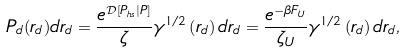Convert formula to latex. <formula><loc_0><loc_0><loc_500><loc_500>P _ { d } ( r _ { d } ) d r _ { d } = \frac { e ^ { \mathcal { D } \left [ P _ { h s } | P \right ] } } { \zeta } \gamma ^ { 1 / 2 } \left ( r _ { d } \right ) d r _ { d } = \frac { e ^ { - \beta F _ { U } } } { \zeta _ { U } } \gamma ^ { 1 / 2 } \left ( r _ { d } \right ) d r _ { d } ,</formula> 